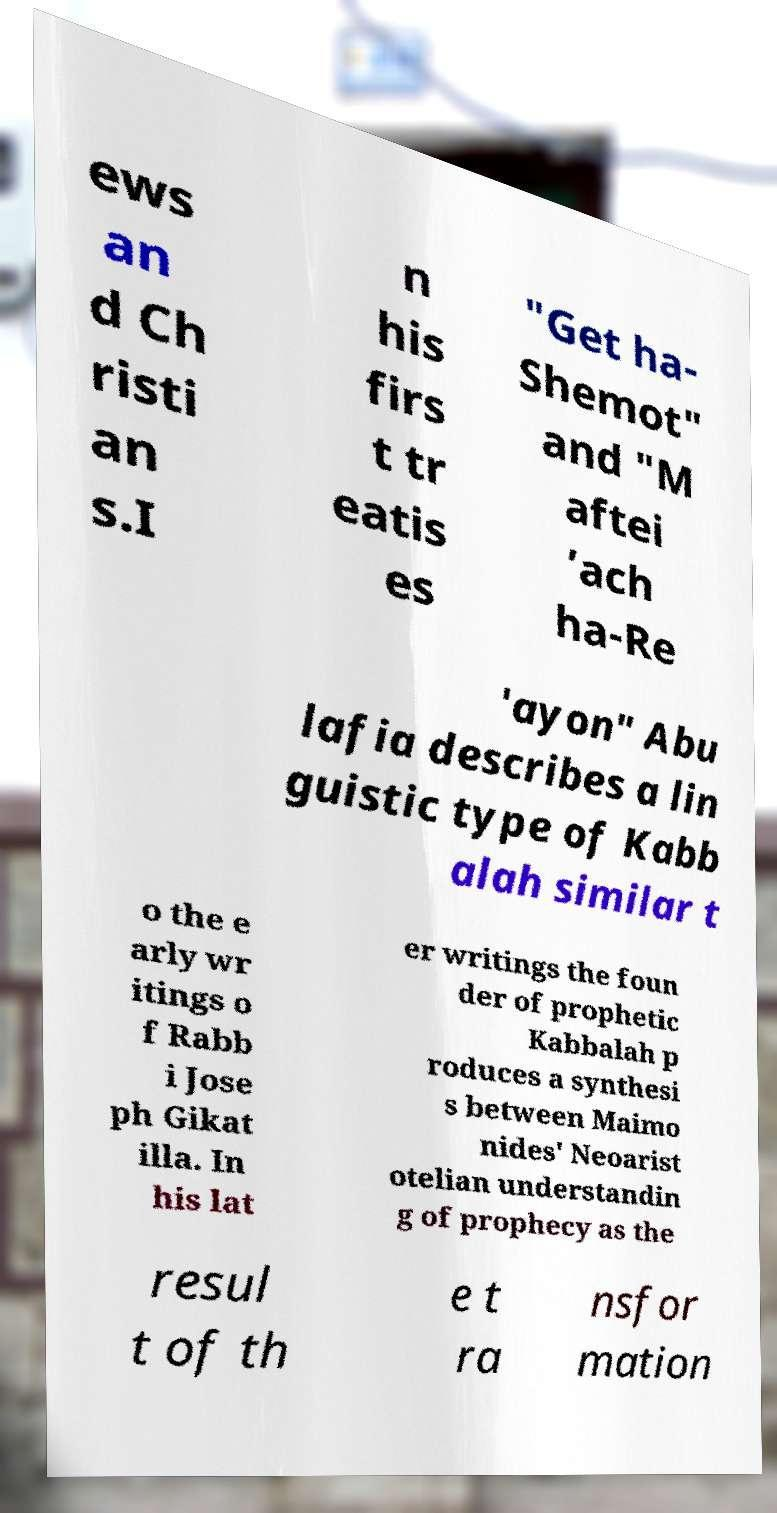Please read and relay the text visible in this image. What does it say? ews an d Ch risti an s.I n his firs t tr eatis es "Get ha- Shemot" and "M aftei ’ach ha-Re 'ayon" Abu lafia describes a lin guistic type of Kabb alah similar t o the e arly wr itings o f Rabb i Jose ph Gikat illa. In his lat er writings the foun der of prophetic Kabbalah p roduces a synthesi s between Maimo nides' Neoarist otelian understandin g of prophecy as the resul t of th e t ra nsfor mation 